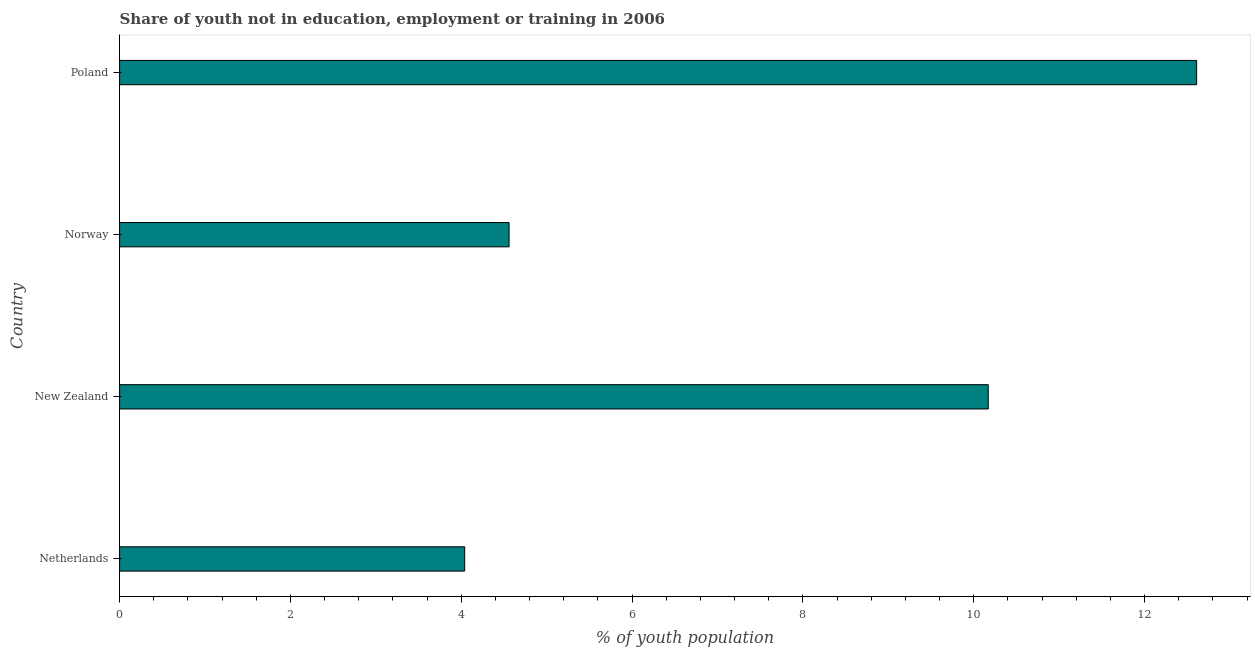Does the graph contain grids?
Offer a terse response. No. What is the title of the graph?
Keep it short and to the point. Share of youth not in education, employment or training in 2006. What is the label or title of the X-axis?
Your response must be concise. % of youth population. What is the label or title of the Y-axis?
Provide a short and direct response. Country. What is the unemployed youth population in Norway?
Keep it short and to the point. 4.56. Across all countries, what is the maximum unemployed youth population?
Your answer should be compact. 12.61. Across all countries, what is the minimum unemployed youth population?
Offer a very short reply. 4.04. In which country was the unemployed youth population minimum?
Make the answer very short. Netherlands. What is the sum of the unemployed youth population?
Your answer should be very brief. 31.38. What is the difference between the unemployed youth population in Netherlands and Poland?
Provide a short and direct response. -8.57. What is the average unemployed youth population per country?
Your answer should be compact. 7.84. What is the median unemployed youth population?
Ensure brevity in your answer.  7.37. What is the ratio of the unemployed youth population in New Zealand to that in Poland?
Offer a terse response. 0.81. Is the unemployed youth population in Netherlands less than that in New Zealand?
Make the answer very short. Yes. What is the difference between the highest and the second highest unemployed youth population?
Offer a very short reply. 2.44. Is the sum of the unemployed youth population in New Zealand and Poland greater than the maximum unemployed youth population across all countries?
Ensure brevity in your answer.  Yes. What is the difference between the highest and the lowest unemployed youth population?
Keep it short and to the point. 8.57. In how many countries, is the unemployed youth population greater than the average unemployed youth population taken over all countries?
Offer a very short reply. 2. How many bars are there?
Provide a succinct answer. 4. Are all the bars in the graph horizontal?
Your answer should be compact. Yes. What is the difference between two consecutive major ticks on the X-axis?
Provide a succinct answer. 2. What is the % of youth population in Netherlands?
Offer a terse response. 4.04. What is the % of youth population of New Zealand?
Ensure brevity in your answer.  10.17. What is the % of youth population in Norway?
Your answer should be compact. 4.56. What is the % of youth population in Poland?
Ensure brevity in your answer.  12.61. What is the difference between the % of youth population in Netherlands and New Zealand?
Your answer should be compact. -6.13. What is the difference between the % of youth population in Netherlands and Norway?
Ensure brevity in your answer.  -0.52. What is the difference between the % of youth population in Netherlands and Poland?
Provide a succinct answer. -8.57. What is the difference between the % of youth population in New Zealand and Norway?
Your response must be concise. 5.61. What is the difference between the % of youth population in New Zealand and Poland?
Ensure brevity in your answer.  -2.44. What is the difference between the % of youth population in Norway and Poland?
Offer a terse response. -8.05. What is the ratio of the % of youth population in Netherlands to that in New Zealand?
Provide a succinct answer. 0.4. What is the ratio of the % of youth population in Netherlands to that in Norway?
Give a very brief answer. 0.89. What is the ratio of the % of youth population in Netherlands to that in Poland?
Your answer should be very brief. 0.32. What is the ratio of the % of youth population in New Zealand to that in Norway?
Provide a succinct answer. 2.23. What is the ratio of the % of youth population in New Zealand to that in Poland?
Your answer should be compact. 0.81. What is the ratio of the % of youth population in Norway to that in Poland?
Your response must be concise. 0.36. 